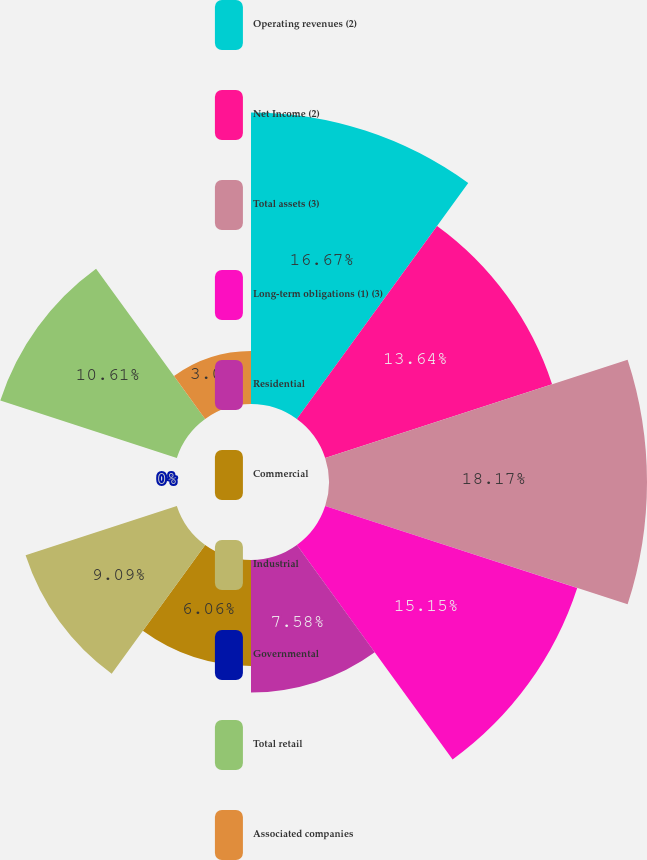<chart> <loc_0><loc_0><loc_500><loc_500><pie_chart><fcel>Operating revenues (2)<fcel>Net Income (2)<fcel>Total assets (3)<fcel>Long-term obligations (1) (3)<fcel>Residential<fcel>Commercial<fcel>Industrial<fcel>Governmental<fcel>Total retail<fcel>Associated companies<nl><fcel>16.67%<fcel>13.64%<fcel>18.18%<fcel>15.15%<fcel>7.58%<fcel>6.06%<fcel>9.09%<fcel>0.0%<fcel>10.61%<fcel>3.03%<nl></chart> 